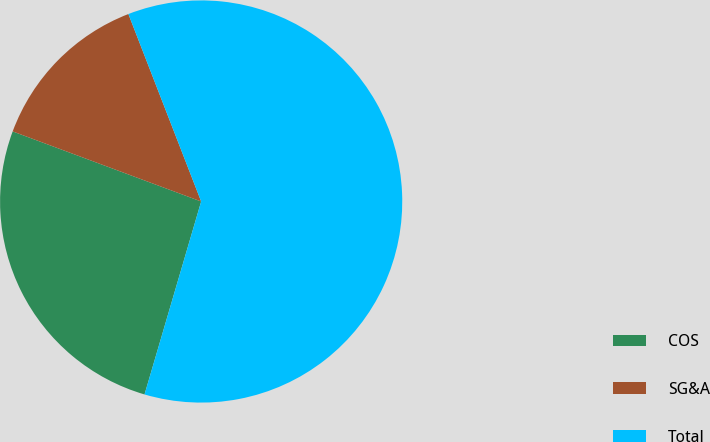Convert chart. <chart><loc_0><loc_0><loc_500><loc_500><pie_chart><fcel>COS<fcel>SG&A<fcel>Total<nl><fcel>26.12%<fcel>13.44%<fcel>60.43%<nl></chart> 